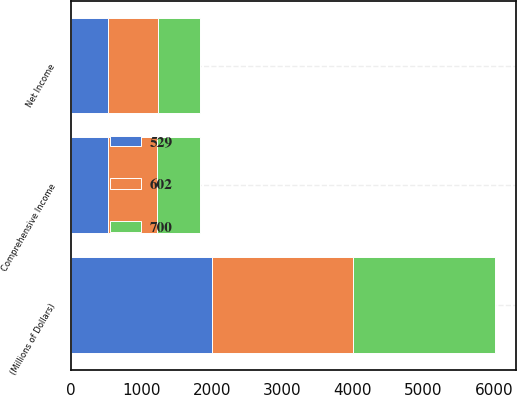Convert chart. <chart><loc_0><loc_0><loc_500><loc_500><stacked_bar_chart><ecel><fcel>(Millions of Dollars)<fcel>Net Income<fcel>Comprehensive Income<nl><fcel>602<fcel>2005<fcel>705<fcel>700<nl><fcel>529<fcel>2004<fcel>529<fcel>529<nl><fcel>700<fcel>2003<fcel>602<fcel>602<nl></chart> 